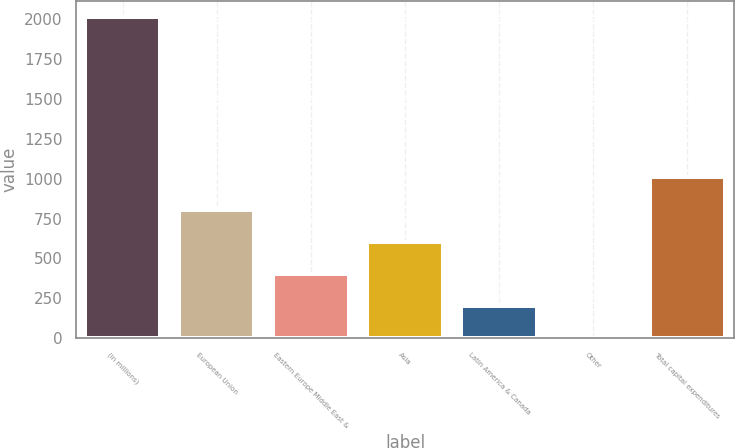<chart> <loc_0><loc_0><loc_500><loc_500><bar_chart><fcel>(in millions)<fcel>European Union<fcel>Eastern Europe Middle East &<fcel>Asia<fcel>Latin America & Canada<fcel>Other<fcel>Total capital expenditures<nl><fcel>2015<fcel>806.6<fcel>403.8<fcel>605.2<fcel>202.4<fcel>1<fcel>1008<nl></chart> 